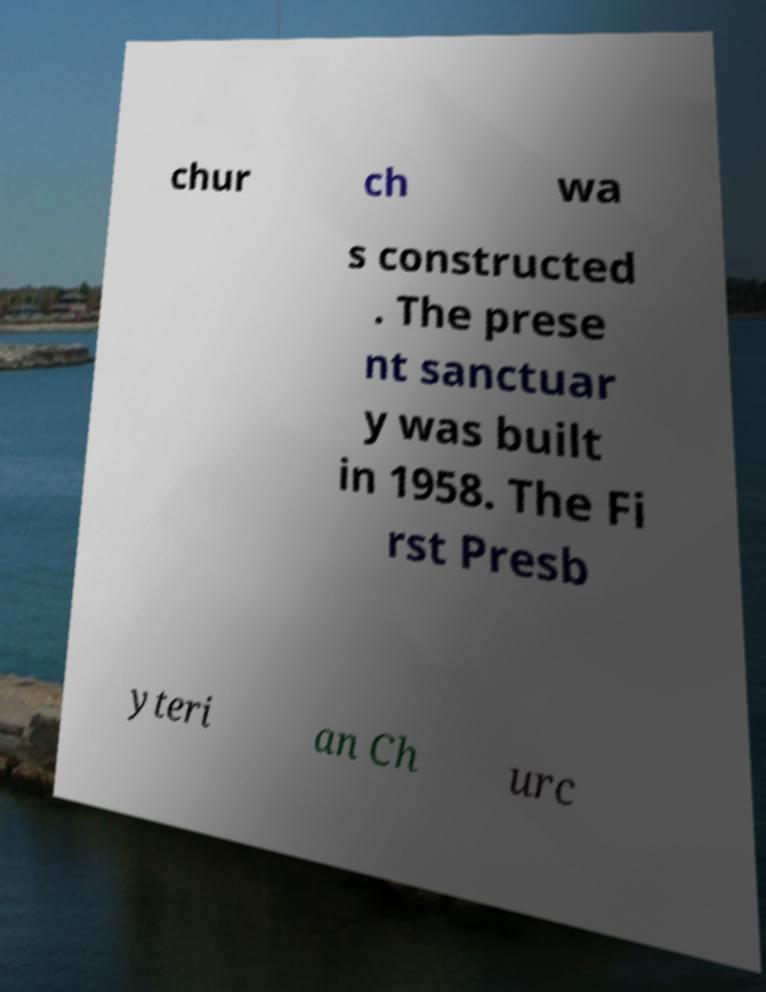There's text embedded in this image that I need extracted. Can you transcribe it verbatim? chur ch wa s constructed . The prese nt sanctuar y was built in 1958. The Fi rst Presb yteri an Ch urc 